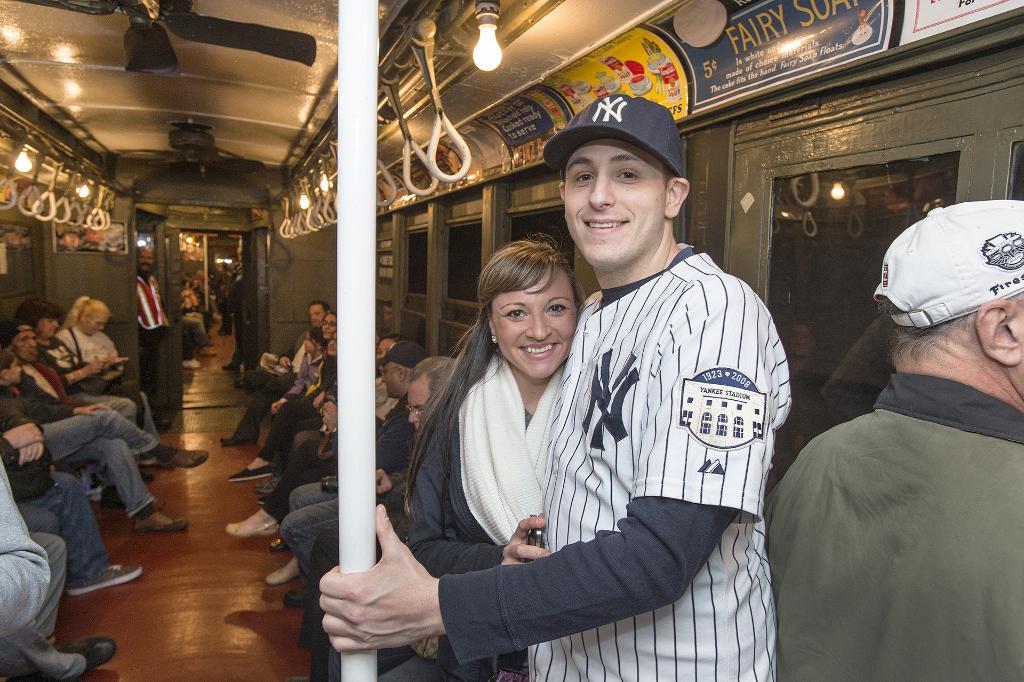They are on the bus or train?
Your response must be concise. Answering does not require reading text in the image. 